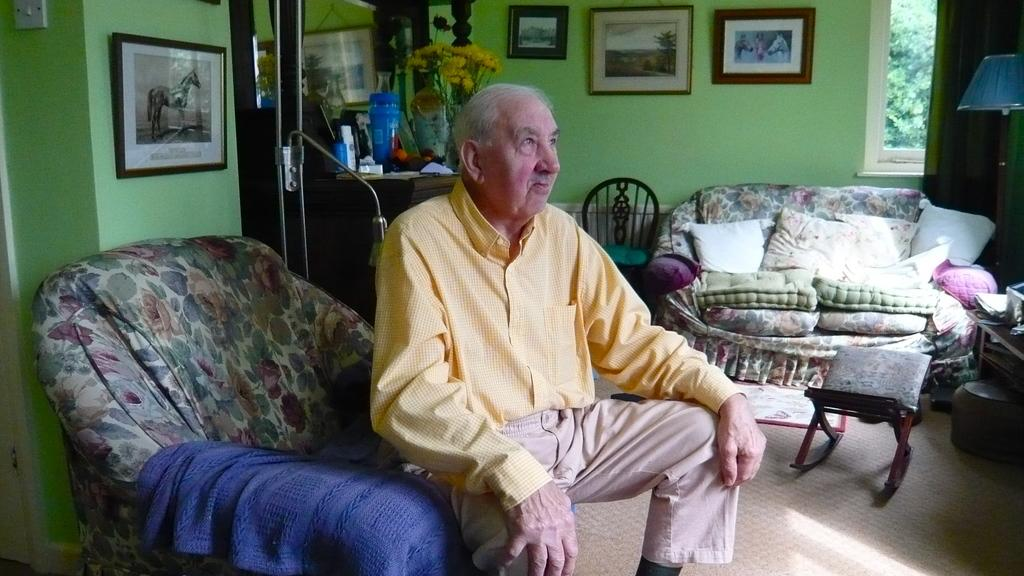What is the man in the image doing? The man is sitting on a chair in the image. What furniture is located near the chair? There is a sofa beside the chair. What can be seen on the sofa? Cushions are placed on the sofa. What color is the wall in the image? The wall has a green color. How many toys are scattered on the floor in the image? There are no toys visible in the image. What type of egg is being cooked on the stove in the image? There is no stove or egg present in the image. 